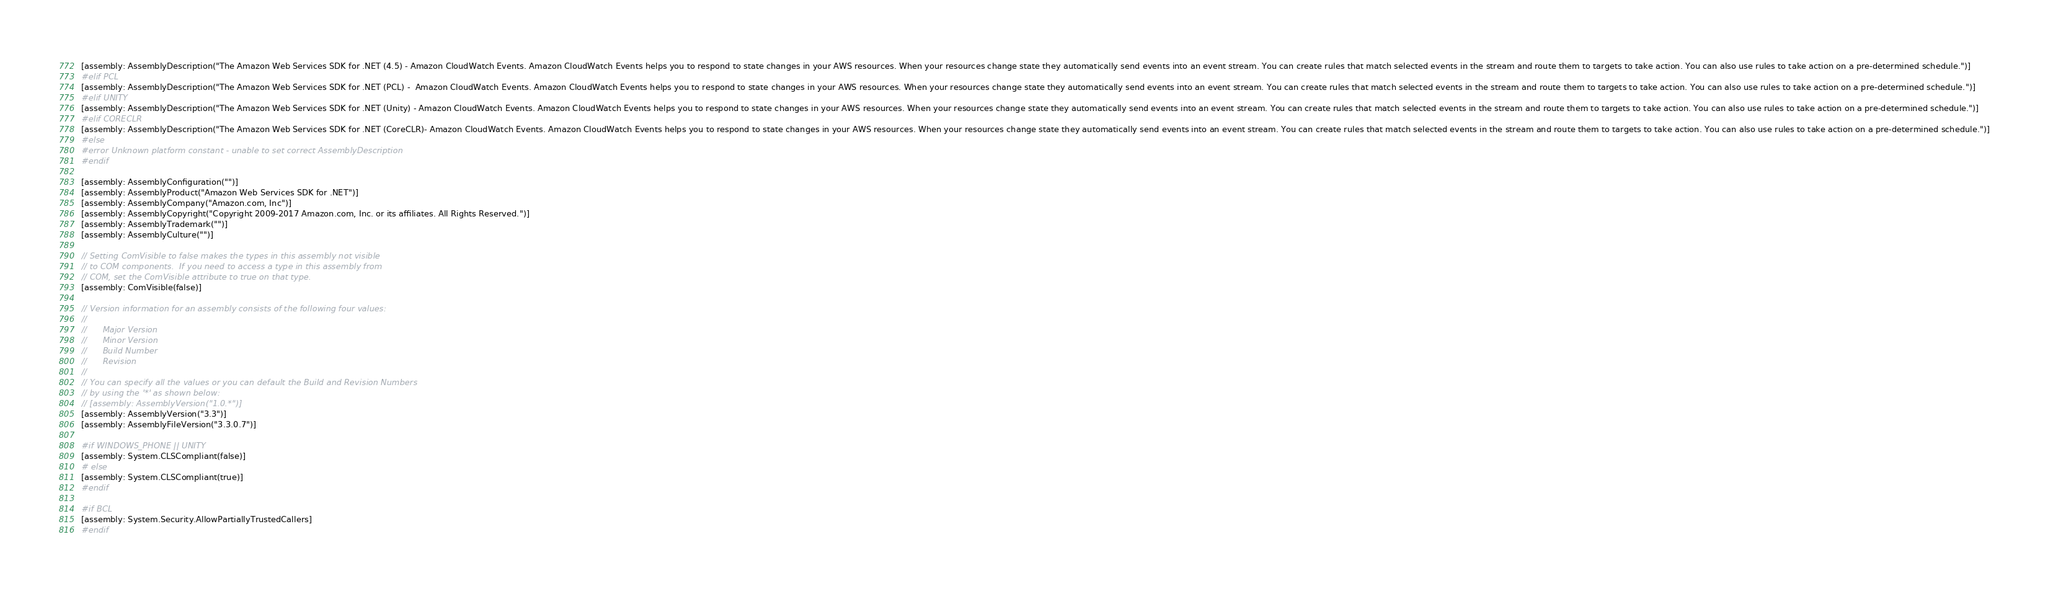Convert code to text. <code><loc_0><loc_0><loc_500><loc_500><_C#_>[assembly: AssemblyDescription("The Amazon Web Services SDK for .NET (4.5) - Amazon CloudWatch Events. Amazon CloudWatch Events helps you to respond to state changes in your AWS resources. When your resources change state they automatically send events into an event stream. You can create rules that match selected events in the stream and route them to targets to take action. You can also use rules to take action on a pre-determined schedule.")]
#elif PCL
[assembly: AssemblyDescription("The Amazon Web Services SDK for .NET (PCL) -  Amazon CloudWatch Events. Amazon CloudWatch Events helps you to respond to state changes in your AWS resources. When your resources change state they automatically send events into an event stream. You can create rules that match selected events in the stream and route them to targets to take action. You can also use rules to take action on a pre-determined schedule.")]
#elif UNITY
[assembly: AssemblyDescription("The Amazon Web Services SDK for .NET (Unity) - Amazon CloudWatch Events. Amazon CloudWatch Events helps you to respond to state changes in your AWS resources. When your resources change state they automatically send events into an event stream. You can create rules that match selected events in the stream and route them to targets to take action. You can also use rules to take action on a pre-determined schedule.")]
#elif CORECLR
[assembly: AssemblyDescription("The Amazon Web Services SDK for .NET (CoreCLR)- Amazon CloudWatch Events. Amazon CloudWatch Events helps you to respond to state changes in your AWS resources. When your resources change state they automatically send events into an event stream. You can create rules that match selected events in the stream and route them to targets to take action. You can also use rules to take action on a pre-determined schedule.")]
#else
#error Unknown platform constant - unable to set correct AssemblyDescription
#endif

[assembly: AssemblyConfiguration("")]
[assembly: AssemblyProduct("Amazon Web Services SDK for .NET")]
[assembly: AssemblyCompany("Amazon.com, Inc")]
[assembly: AssemblyCopyright("Copyright 2009-2017 Amazon.com, Inc. or its affiliates. All Rights Reserved.")]
[assembly: AssemblyTrademark("")]
[assembly: AssemblyCulture("")]

// Setting ComVisible to false makes the types in this assembly not visible 
// to COM components.  If you need to access a type in this assembly from 
// COM, set the ComVisible attribute to true on that type.
[assembly: ComVisible(false)]

// Version information for an assembly consists of the following four values:
//
//      Major Version
//      Minor Version 
//      Build Number
//      Revision
//
// You can specify all the values or you can default the Build and Revision Numbers 
// by using the '*' as shown below:
// [assembly: AssemblyVersion("1.0.*")]
[assembly: AssemblyVersion("3.3")]
[assembly: AssemblyFileVersion("3.3.0.7")]

#if WINDOWS_PHONE || UNITY
[assembly: System.CLSCompliant(false)]
# else
[assembly: System.CLSCompliant(true)]
#endif

#if BCL
[assembly: System.Security.AllowPartiallyTrustedCallers]
#endif</code> 